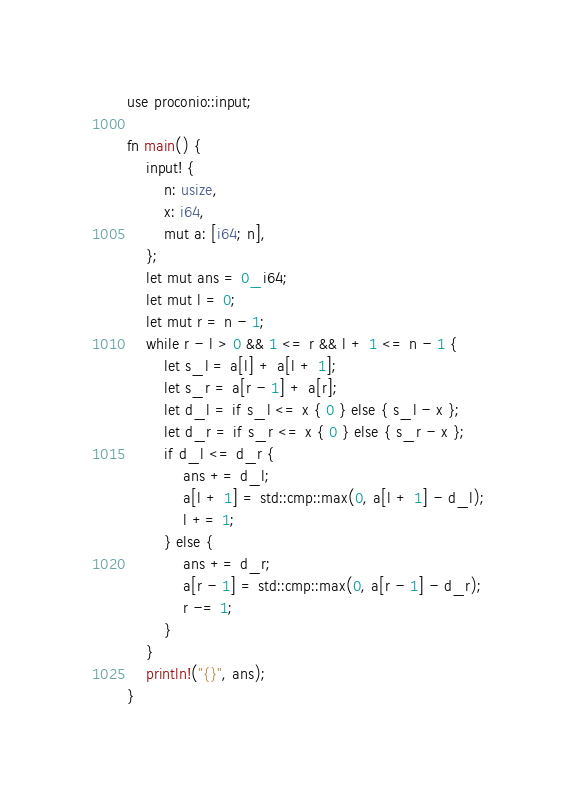Convert code to text. <code><loc_0><loc_0><loc_500><loc_500><_Rust_>use proconio::input;

fn main() {
    input! {
        n: usize,
        x: i64,
        mut a: [i64; n],
    };
    let mut ans = 0_i64;
    let mut l = 0;
    let mut r = n - 1;
    while r - l > 0 && 1 <= r && l + 1 <= n - 1 {
        let s_l = a[l] + a[l + 1];
        let s_r = a[r - 1] + a[r];
        let d_l = if s_l <= x { 0 } else { s_l - x };
        let d_r = if s_r <= x { 0 } else { s_r - x };
        if d_l <= d_r {
            ans += d_l;
            a[l + 1] = std::cmp::max(0, a[l + 1] - d_l);
            l += 1;
        } else {
            ans += d_r;
            a[r - 1] = std::cmp::max(0, a[r - 1] - d_r);
            r -= 1;
        }
    }
    println!("{}", ans);
}
</code> 